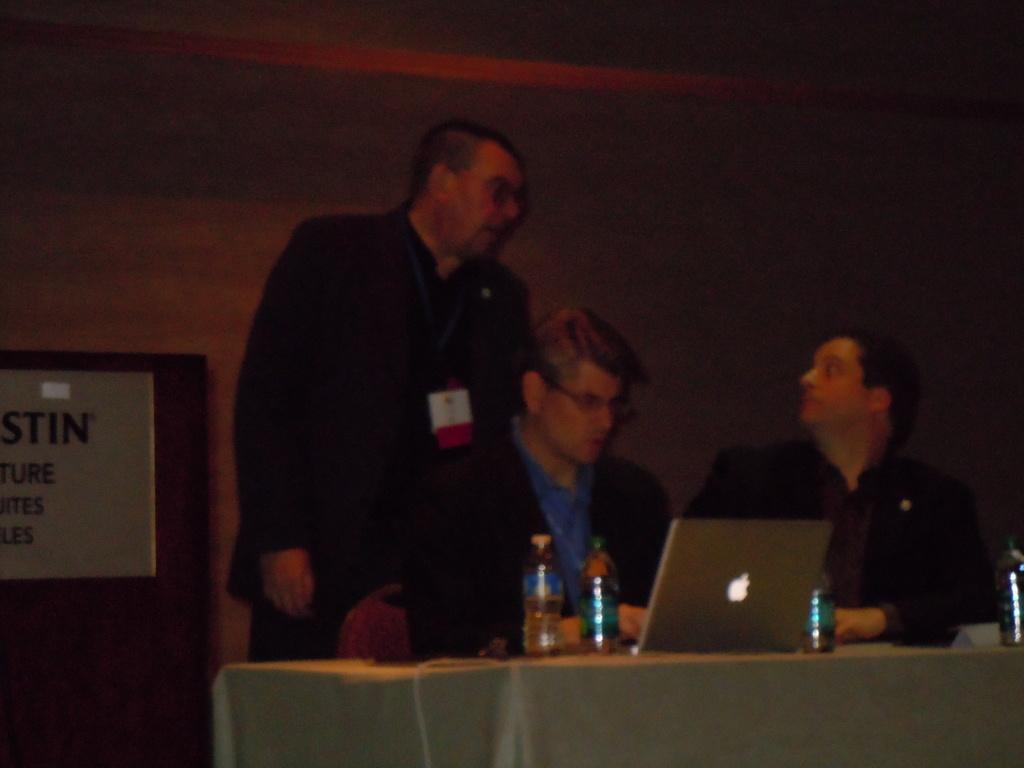Could you give a brief overview of what you see in this image? In this picture I can see two people sitting on the chair. I can see a person standing on the surface. I can see the bottles and electronic devices on the table. 